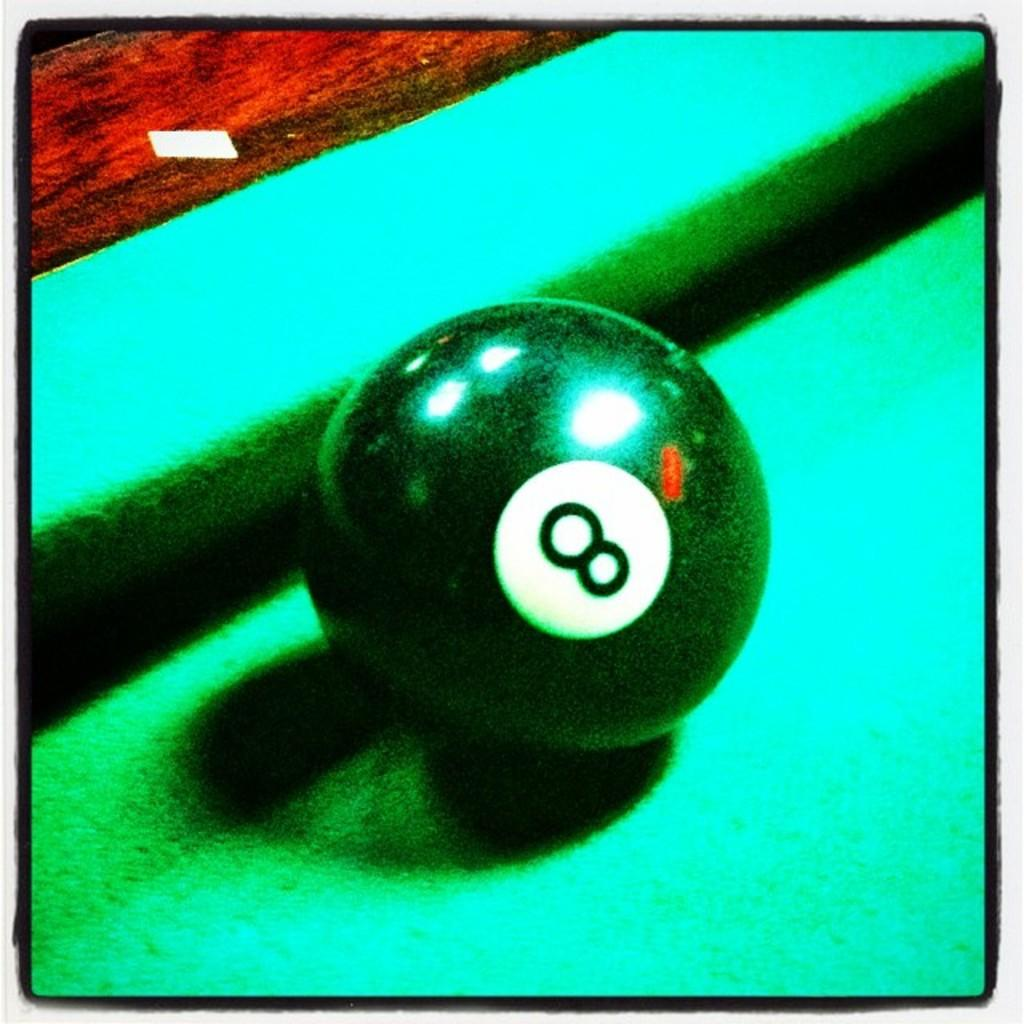What object is the main focus of the image? There is a billiard ball in the image. Where is the billiard ball located? The billiard ball is on a table. Can you describe any other features of the image? The image has borders. Can you see any boats or fish in the image? No, there are no boats or fish present in the image. Is there a playground visible in the image? No, there is no playground in the image. 